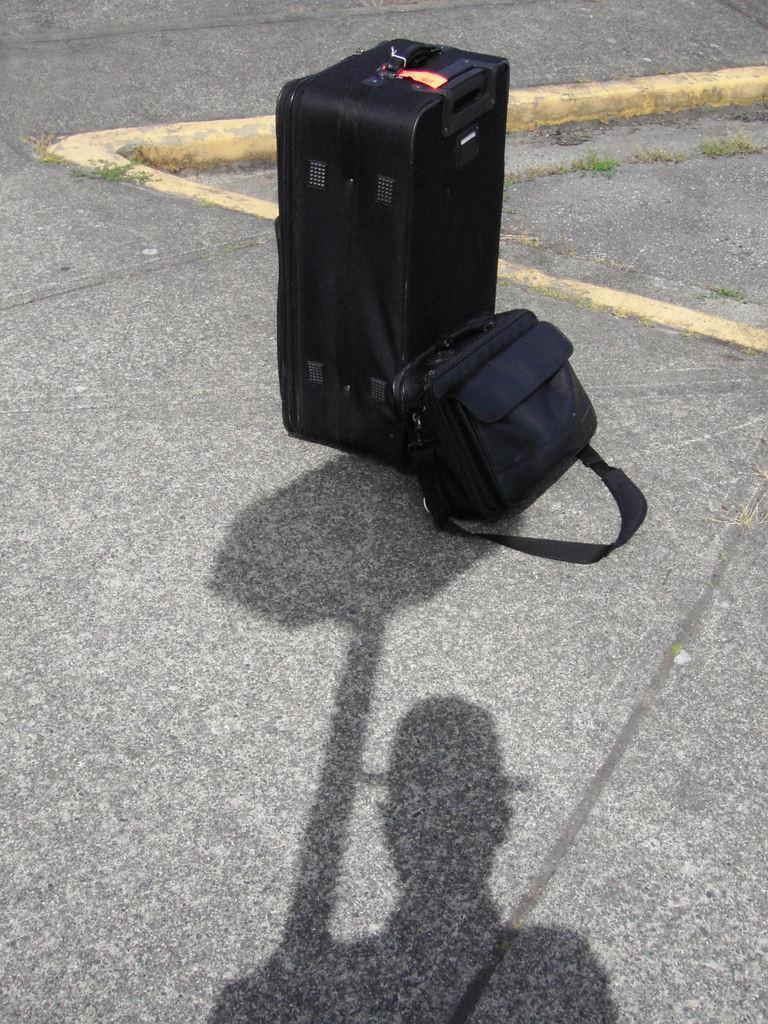How would you summarize this image in a sentence or two? This is the road and there are two bags on the roads. This is the shadow of the man who is wearing hat on his head. 